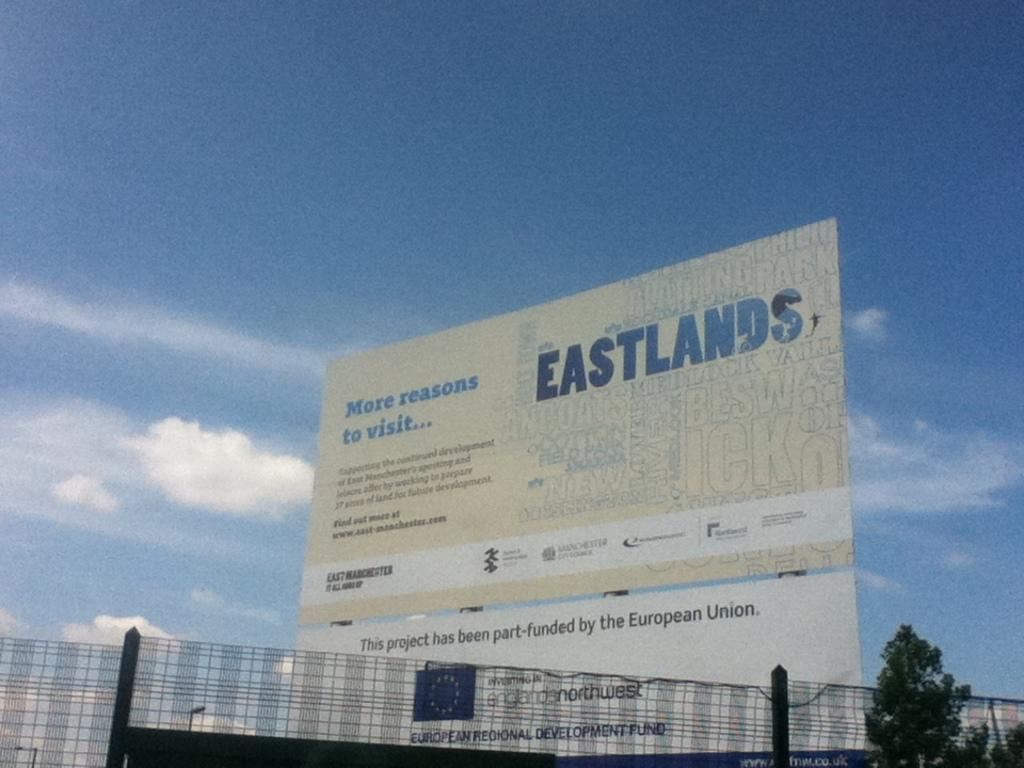<image>
Share a concise interpretation of the image provided. A sign for Eastlands promises, "More reasons to visit." 